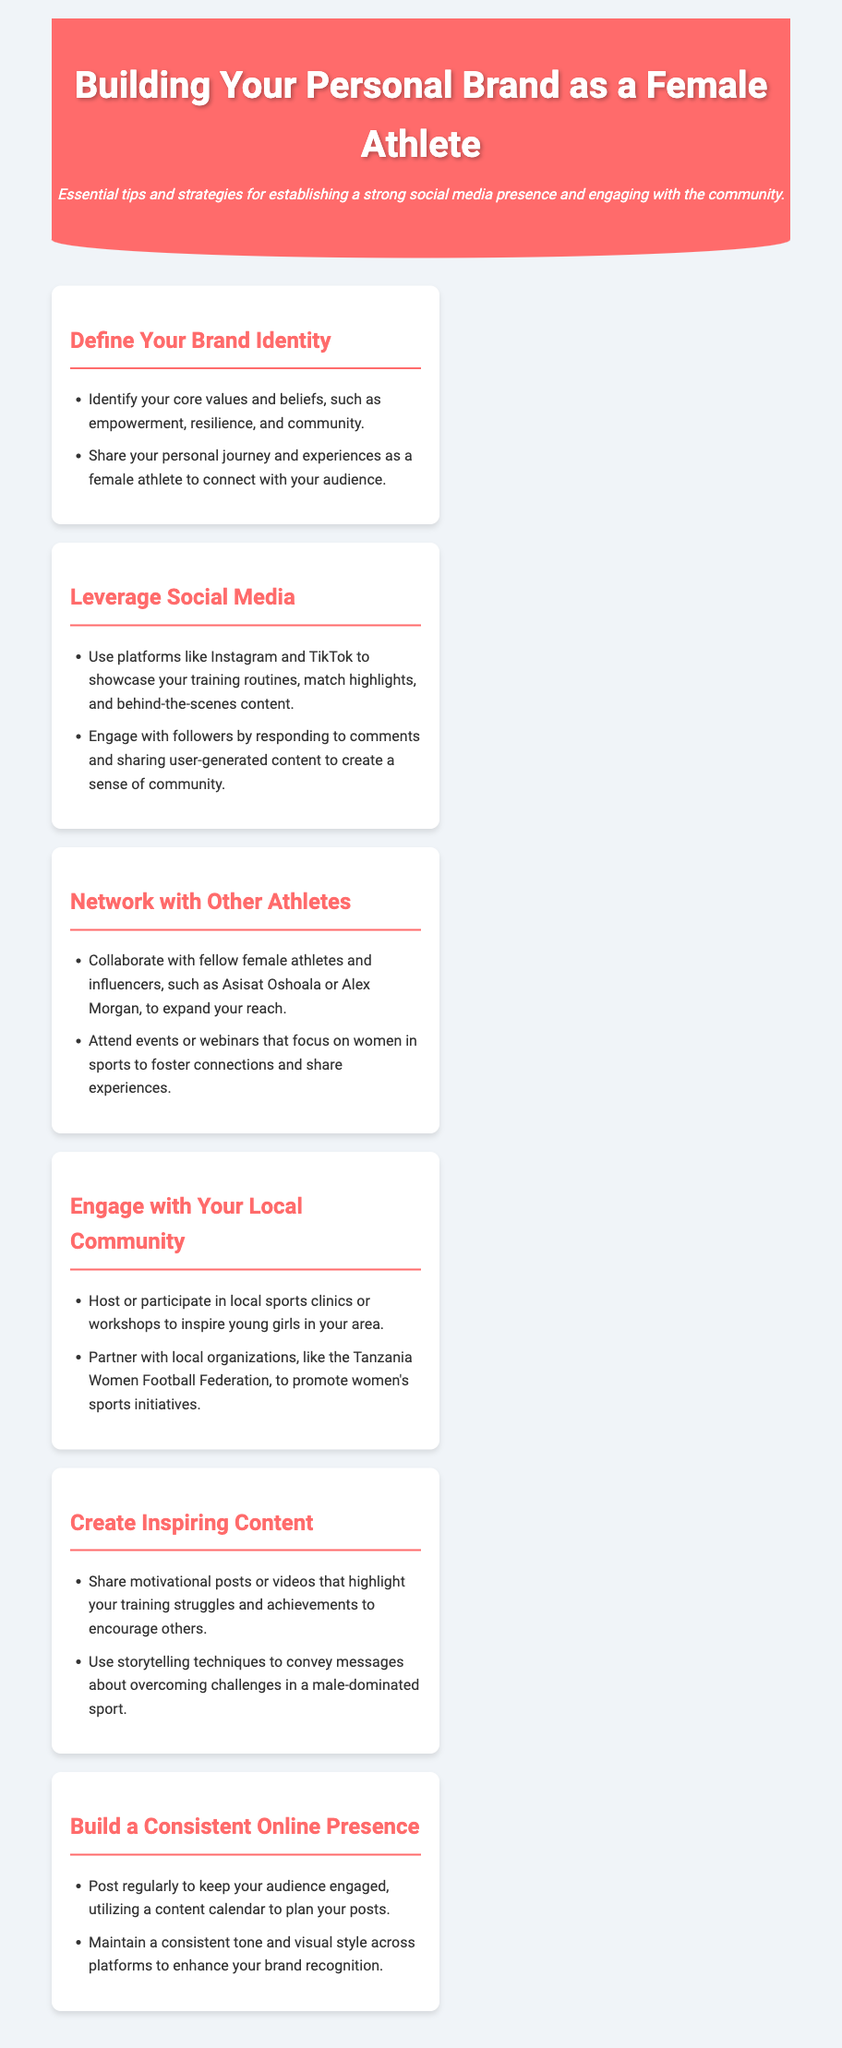What is the primary focus of the document? The document provides tips and strategies for female athletes to build a personal brand through social media and community engagement.
Answer: building a personal brand as a female athlete Which social media platforms are suggested for showcasing content? The document mentions specific platforms where athletes can share their content, which are Instagram and TikTok.
Answer: Instagram and TikTok What type of events should athletes attend to network with others? The document recommends attending events or webinars that focus on women in sports, which helps in networking.
Answer: women in sports events How can female athletes engage with their local community? The document suggests hosting or participating in sports clinics or workshops aimed at inspiring young girls.
Answer: sports clinics or workshops What is a crucial aspect of maintaining a social media presence? The document highlights the importance of posting regularly and maintaining a consistent tone and visual style.
Answer: posting regularly Who are some female athletes mentioned for possible collaboration? The document provides specific examples of athletes with whom you can collaborate, including Asisat Oshoala and Alex Morgan.
Answer: Asisat Oshoala, Alex Morgan What should you include in content to inspire your audience? The document stresses the importance of sharing motivational posts that highlight training struggles and achievements.
Answer: motivational posts What is a recommended strategy for expanding reach in networking? The document advises collaborations with fellow female athletes and influencers to broaden audience engagement.
Answer: collaborate with fellow female athletes 